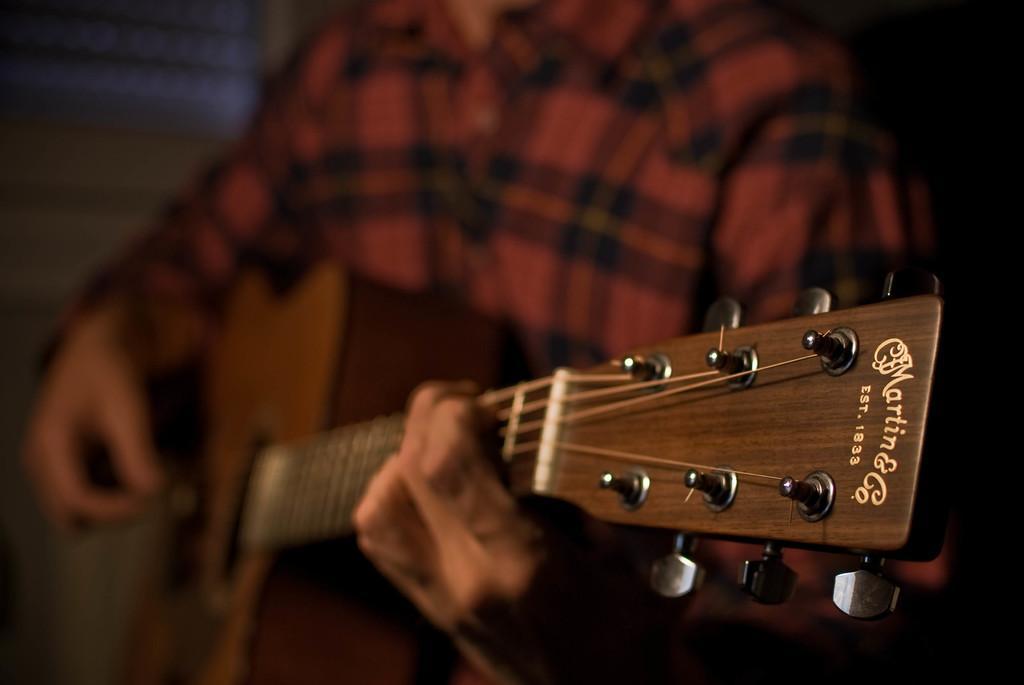Please provide a concise description of this image. This picture is little blurry. We can see a person playing a guitar. 